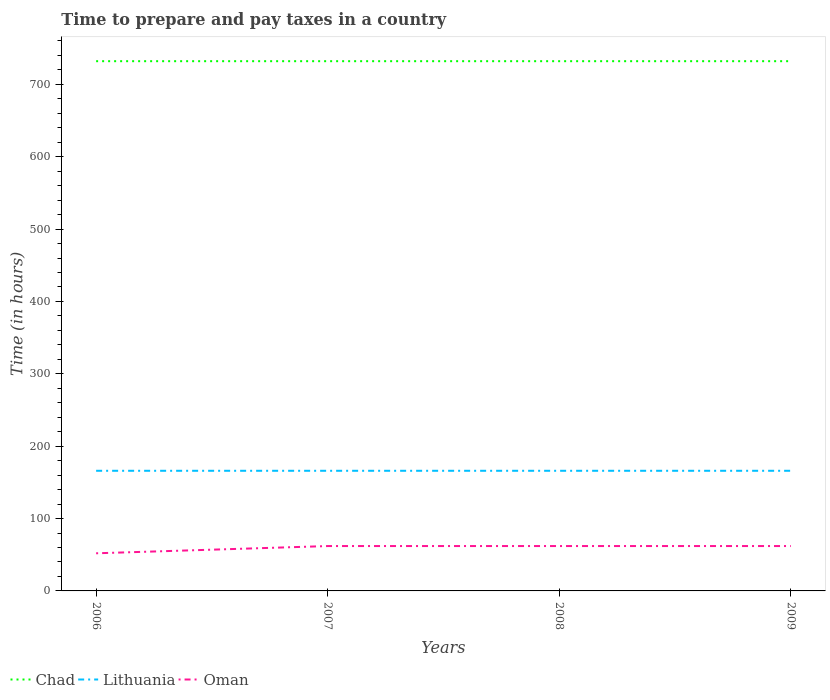How many different coloured lines are there?
Give a very brief answer. 3. Is the number of lines equal to the number of legend labels?
Offer a very short reply. Yes. Across all years, what is the maximum number of hours required to prepare and pay taxes in Oman?
Your answer should be compact. 52. What is the difference between the highest and the second highest number of hours required to prepare and pay taxes in Chad?
Your response must be concise. 0. Is the number of hours required to prepare and pay taxes in Chad strictly greater than the number of hours required to prepare and pay taxes in Lithuania over the years?
Offer a terse response. No. What is the difference between two consecutive major ticks on the Y-axis?
Make the answer very short. 100. How many legend labels are there?
Make the answer very short. 3. What is the title of the graph?
Offer a very short reply. Time to prepare and pay taxes in a country. Does "Tuvalu" appear as one of the legend labels in the graph?
Offer a very short reply. No. What is the label or title of the X-axis?
Offer a terse response. Years. What is the label or title of the Y-axis?
Give a very brief answer. Time (in hours). What is the Time (in hours) in Chad in 2006?
Your response must be concise. 732. What is the Time (in hours) in Lithuania in 2006?
Provide a short and direct response. 166. What is the Time (in hours) in Oman in 2006?
Offer a very short reply. 52. What is the Time (in hours) of Chad in 2007?
Your response must be concise. 732. What is the Time (in hours) of Lithuania in 2007?
Your answer should be compact. 166. What is the Time (in hours) of Oman in 2007?
Provide a short and direct response. 62. What is the Time (in hours) in Chad in 2008?
Your answer should be very brief. 732. What is the Time (in hours) of Lithuania in 2008?
Your answer should be very brief. 166. What is the Time (in hours) in Chad in 2009?
Your answer should be compact. 732. What is the Time (in hours) in Lithuania in 2009?
Offer a very short reply. 166. Across all years, what is the maximum Time (in hours) of Chad?
Your answer should be compact. 732. Across all years, what is the maximum Time (in hours) of Lithuania?
Keep it short and to the point. 166. Across all years, what is the maximum Time (in hours) of Oman?
Make the answer very short. 62. Across all years, what is the minimum Time (in hours) in Chad?
Keep it short and to the point. 732. Across all years, what is the minimum Time (in hours) in Lithuania?
Give a very brief answer. 166. What is the total Time (in hours) in Chad in the graph?
Offer a terse response. 2928. What is the total Time (in hours) in Lithuania in the graph?
Offer a very short reply. 664. What is the total Time (in hours) in Oman in the graph?
Offer a terse response. 238. What is the difference between the Time (in hours) in Chad in 2006 and that in 2007?
Provide a short and direct response. 0. What is the difference between the Time (in hours) in Oman in 2006 and that in 2008?
Provide a short and direct response. -10. What is the difference between the Time (in hours) of Lithuania in 2006 and that in 2009?
Offer a terse response. 0. What is the difference between the Time (in hours) of Chad in 2007 and that in 2009?
Ensure brevity in your answer.  0. What is the difference between the Time (in hours) of Lithuania in 2007 and that in 2009?
Ensure brevity in your answer.  0. What is the difference between the Time (in hours) in Chad in 2008 and that in 2009?
Offer a terse response. 0. What is the difference between the Time (in hours) in Lithuania in 2008 and that in 2009?
Make the answer very short. 0. What is the difference between the Time (in hours) of Chad in 2006 and the Time (in hours) of Lithuania in 2007?
Offer a terse response. 566. What is the difference between the Time (in hours) in Chad in 2006 and the Time (in hours) in Oman in 2007?
Give a very brief answer. 670. What is the difference between the Time (in hours) of Lithuania in 2006 and the Time (in hours) of Oman in 2007?
Your answer should be compact. 104. What is the difference between the Time (in hours) of Chad in 2006 and the Time (in hours) of Lithuania in 2008?
Make the answer very short. 566. What is the difference between the Time (in hours) of Chad in 2006 and the Time (in hours) of Oman in 2008?
Make the answer very short. 670. What is the difference between the Time (in hours) of Lithuania in 2006 and the Time (in hours) of Oman in 2008?
Offer a very short reply. 104. What is the difference between the Time (in hours) in Chad in 2006 and the Time (in hours) in Lithuania in 2009?
Provide a succinct answer. 566. What is the difference between the Time (in hours) in Chad in 2006 and the Time (in hours) in Oman in 2009?
Keep it short and to the point. 670. What is the difference between the Time (in hours) in Lithuania in 2006 and the Time (in hours) in Oman in 2009?
Your response must be concise. 104. What is the difference between the Time (in hours) in Chad in 2007 and the Time (in hours) in Lithuania in 2008?
Make the answer very short. 566. What is the difference between the Time (in hours) of Chad in 2007 and the Time (in hours) of Oman in 2008?
Offer a very short reply. 670. What is the difference between the Time (in hours) of Lithuania in 2007 and the Time (in hours) of Oman in 2008?
Give a very brief answer. 104. What is the difference between the Time (in hours) in Chad in 2007 and the Time (in hours) in Lithuania in 2009?
Offer a very short reply. 566. What is the difference between the Time (in hours) of Chad in 2007 and the Time (in hours) of Oman in 2009?
Your answer should be very brief. 670. What is the difference between the Time (in hours) of Lithuania in 2007 and the Time (in hours) of Oman in 2009?
Offer a very short reply. 104. What is the difference between the Time (in hours) of Chad in 2008 and the Time (in hours) of Lithuania in 2009?
Give a very brief answer. 566. What is the difference between the Time (in hours) of Chad in 2008 and the Time (in hours) of Oman in 2009?
Offer a terse response. 670. What is the difference between the Time (in hours) of Lithuania in 2008 and the Time (in hours) of Oman in 2009?
Offer a very short reply. 104. What is the average Time (in hours) of Chad per year?
Your response must be concise. 732. What is the average Time (in hours) of Lithuania per year?
Ensure brevity in your answer.  166. What is the average Time (in hours) in Oman per year?
Provide a succinct answer. 59.5. In the year 2006, what is the difference between the Time (in hours) of Chad and Time (in hours) of Lithuania?
Offer a very short reply. 566. In the year 2006, what is the difference between the Time (in hours) of Chad and Time (in hours) of Oman?
Make the answer very short. 680. In the year 2006, what is the difference between the Time (in hours) of Lithuania and Time (in hours) of Oman?
Offer a terse response. 114. In the year 2007, what is the difference between the Time (in hours) in Chad and Time (in hours) in Lithuania?
Provide a succinct answer. 566. In the year 2007, what is the difference between the Time (in hours) of Chad and Time (in hours) of Oman?
Your answer should be very brief. 670. In the year 2007, what is the difference between the Time (in hours) of Lithuania and Time (in hours) of Oman?
Provide a short and direct response. 104. In the year 2008, what is the difference between the Time (in hours) in Chad and Time (in hours) in Lithuania?
Ensure brevity in your answer.  566. In the year 2008, what is the difference between the Time (in hours) of Chad and Time (in hours) of Oman?
Your answer should be very brief. 670. In the year 2008, what is the difference between the Time (in hours) in Lithuania and Time (in hours) in Oman?
Offer a very short reply. 104. In the year 2009, what is the difference between the Time (in hours) of Chad and Time (in hours) of Lithuania?
Offer a very short reply. 566. In the year 2009, what is the difference between the Time (in hours) of Chad and Time (in hours) of Oman?
Offer a terse response. 670. In the year 2009, what is the difference between the Time (in hours) of Lithuania and Time (in hours) of Oman?
Provide a short and direct response. 104. What is the ratio of the Time (in hours) in Lithuania in 2006 to that in 2007?
Your answer should be very brief. 1. What is the ratio of the Time (in hours) of Oman in 2006 to that in 2007?
Offer a very short reply. 0.84. What is the ratio of the Time (in hours) in Lithuania in 2006 to that in 2008?
Provide a succinct answer. 1. What is the ratio of the Time (in hours) of Oman in 2006 to that in 2008?
Make the answer very short. 0.84. What is the ratio of the Time (in hours) of Lithuania in 2006 to that in 2009?
Provide a short and direct response. 1. What is the ratio of the Time (in hours) in Oman in 2006 to that in 2009?
Provide a short and direct response. 0.84. What is the ratio of the Time (in hours) of Chad in 2007 to that in 2009?
Keep it short and to the point. 1. What is the ratio of the Time (in hours) in Lithuania in 2007 to that in 2009?
Your answer should be very brief. 1. What is the ratio of the Time (in hours) in Oman in 2007 to that in 2009?
Your answer should be compact. 1. What is the ratio of the Time (in hours) of Lithuania in 2008 to that in 2009?
Your response must be concise. 1. What is the ratio of the Time (in hours) of Oman in 2008 to that in 2009?
Your response must be concise. 1. What is the difference between the highest and the second highest Time (in hours) of Lithuania?
Ensure brevity in your answer.  0. What is the difference between the highest and the second highest Time (in hours) in Oman?
Your answer should be very brief. 0. What is the difference between the highest and the lowest Time (in hours) of Lithuania?
Provide a succinct answer. 0. What is the difference between the highest and the lowest Time (in hours) of Oman?
Keep it short and to the point. 10. 